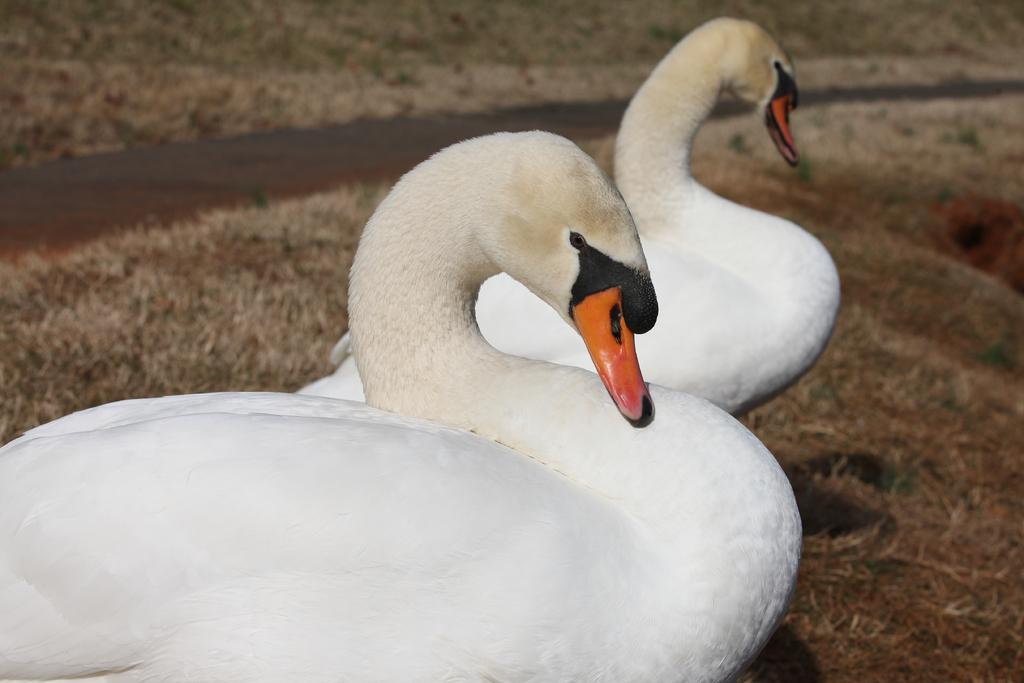What animals are present in the image? There are two swans in the image. Which direction are the swans facing? The swans are facing towards the right side. What type of terrain is visible at the bottom of the image? There is grass visible at the bottom of the image. What body of water is present in the image? There is a lake on the left side of the image. What type of jewel is the doctor using for the activity in the image? There is no doctor or jewel present in the image; it features two swans and a lake. 